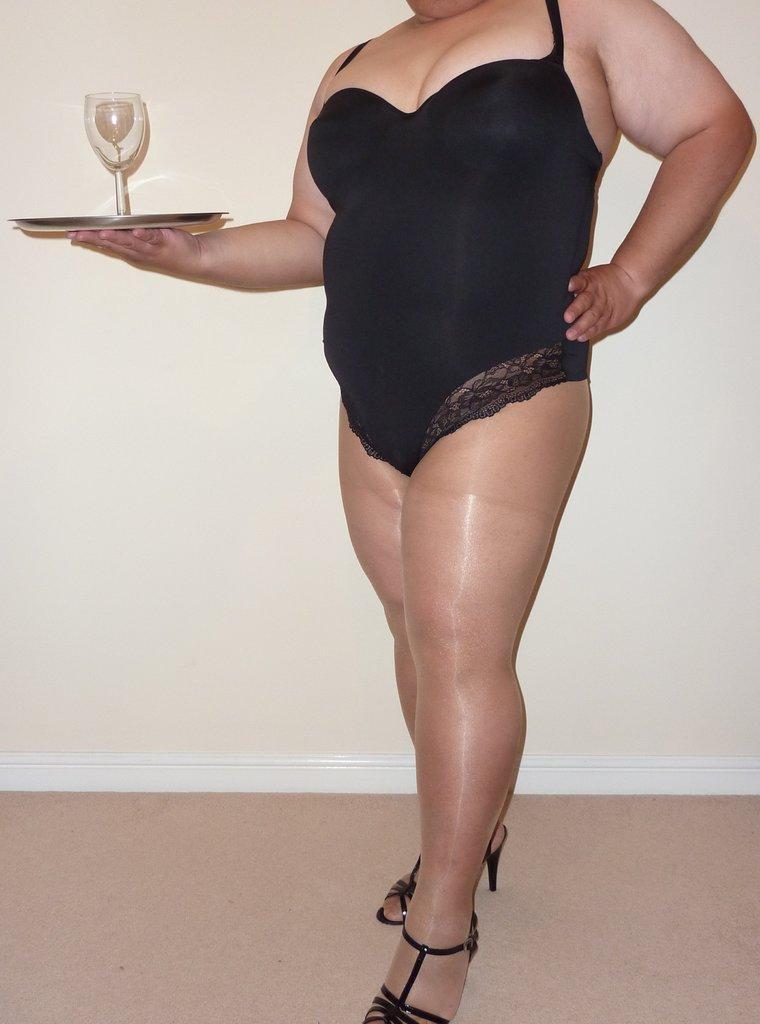Could you give a brief overview of what you see in this image? In this image we can see a woman. She is holding a plate and a glass in her hand. In the background, we can see the wall. At the bottom of the image, we can see the carpet on the floor. 